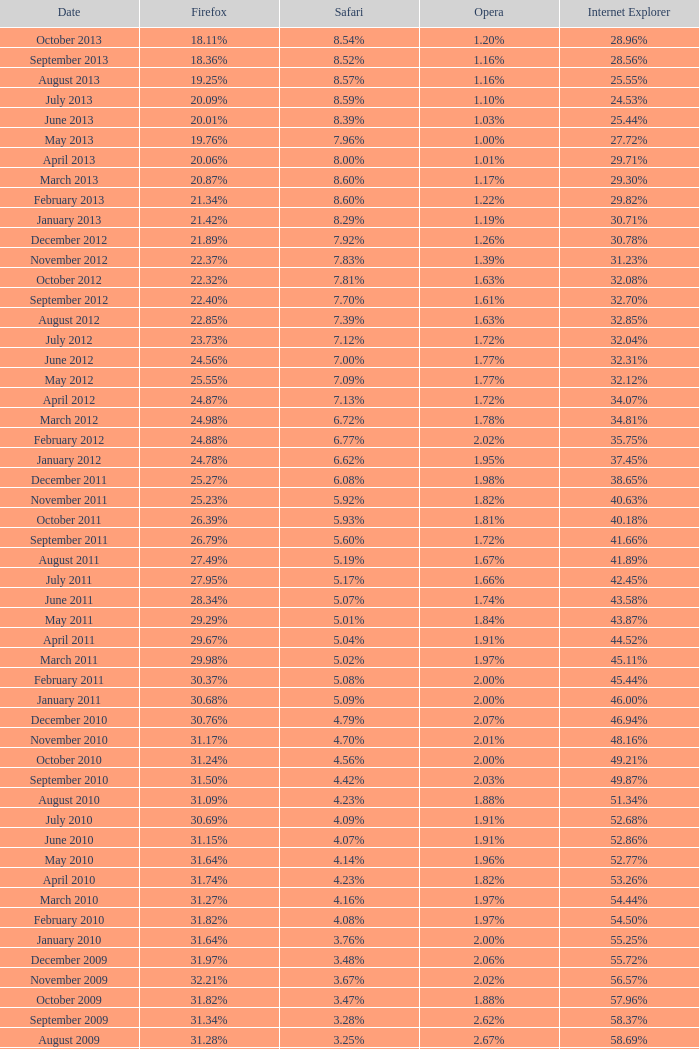What percentage of browsers were using Opera in November 2009? 2.02%. 